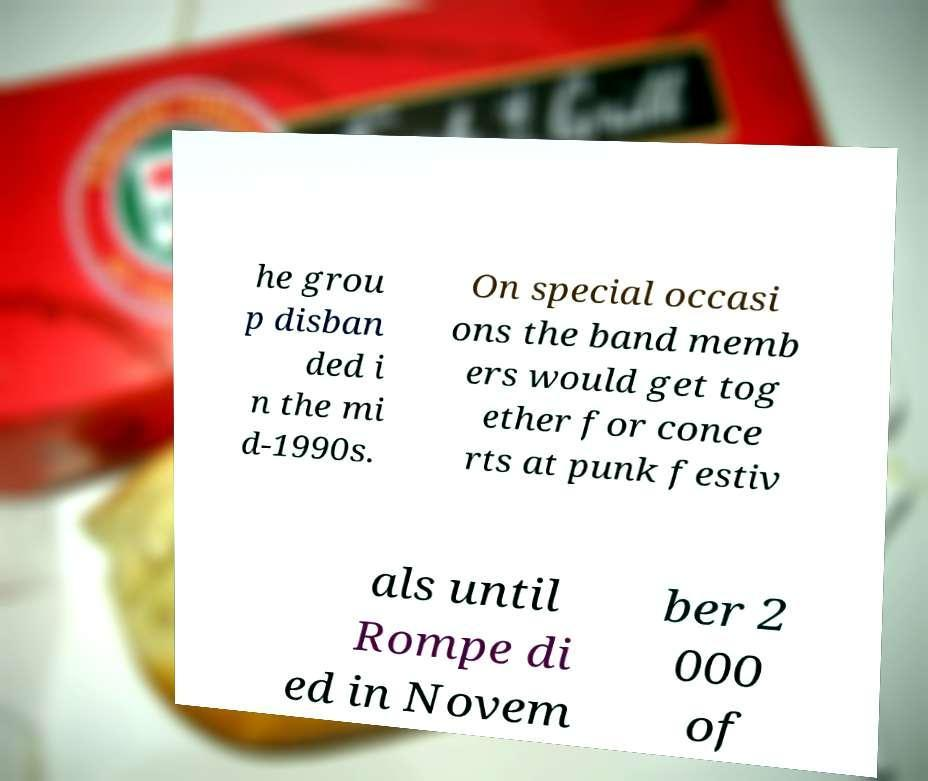Could you assist in decoding the text presented in this image and type it out clearly? he grou p disban ded i n the mi d-1990s. On special occasi ons the band memb ers would get tog ether for conce rts at punk festiv als until Rompe di ed in Novem ber 2 000 of 